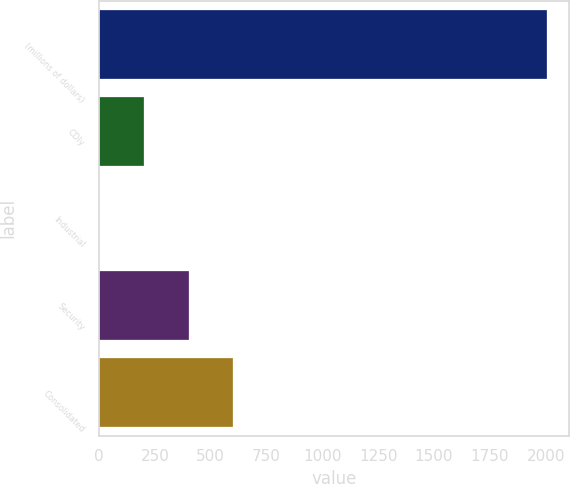Convert chart. <chart><loc_0><loc_0><loc_500><loc_500><bar_chart><fcel>(millions of dollars)<fcel>CDIy<fcel>Industrial<fcel>Security<fcel>Consolidated<nl><fcel>2005<fcel>200.86<fcel>0.4<fcel>401.32<fcel>601.78<nl></chart> 